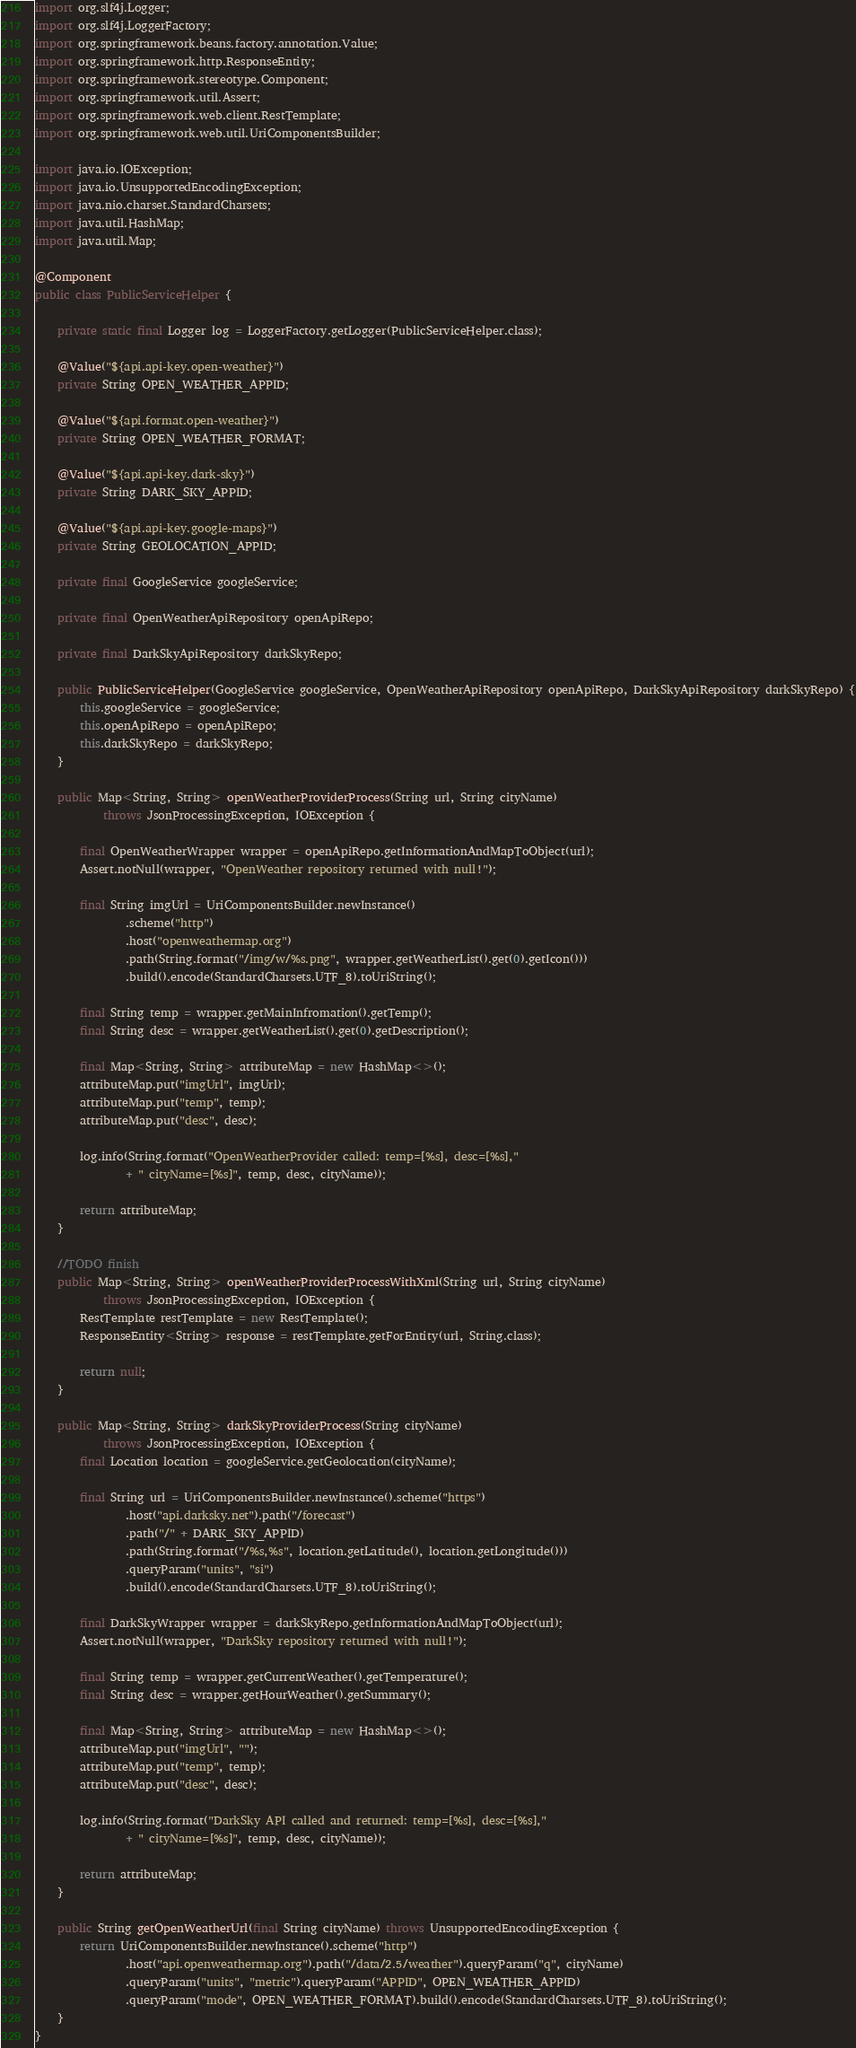<code> <loc_0><loc_0><loc_500><loc_500><_Java_>import org.slf4j.Logger;
import org.slf4j.LoggerFactory;
import org.springframework.beans.factory.annotation.Value;
import org.springframework.http.ResponseEntity;
import org.springframework.stereotype.Component;
import org.springframework.util.Assert;
import org.springframework.web.client.RestTemplate;
import org.springframework.web.util.UriComponentsBuilder;

import java.io.IOException;
import java.io.UnsupportedEncodingException;
import java.nio.charset.StandardCharsets;
import java.util.HashMap;
import java.util.Map;

@Component
public class PublicServiceHelper {
    
    private static final Logger log = LoggerFactory.getLogger(PublicServiceHelper.class);
    
    @Value("${api.api-key.open-weather}")
    private String OPEN_WEATHER_APPID;

    @Value("${api.format.open-weather}")
    private String OPEN_WEATHER_FORMAT;

    @Value("${api.api-key.dark-sky}")
    private String DARK_SKY_APPID;

    @Value("${api.api-key.google-maps}")
    private String GEOLOCATION_APPID;
    
    private final GoogleService googleService;
    
    private final OpenWeatherApiRepository openApiRepo;
    
    private final DarkSkyApiRepository darkSkyRepo;
    
    public PublicServiceHelper(GoogleService googleService, OpenWeatherApiRepository openApiRepo, DarkSkyApiRepository darkSkyRepo) {
        this.googleService = googleService;
        this.openApiRepo = openApiRepo;
        this.darkSkyRepo = darkSkyRepo;
    }

    public Map<String, String> openWeatherProviderProcess(String url, String cityName)
            throws JsonProcessingException, IOException {

        final OpenWeatherWrapper wrapper = openApiRepo.getInformationAndMapToObject(url);
        Assert.notNull(wrapper, "OpenWeather repository returned with null!");

        final String imgUrl = UriComponentsBuilder.newInstance()
                .scheme("http")
                .host("openweathermap.org")
                .path(String.format("/img/w/%s.png", wrapper.getWeatherList().get(0).getIcon()))
                .build().encode(StandardCharsets.UTF_8).toUriString();
                        
        final String temp = wrapper.getMainInfromation().getTemp();
        final String desc = wrapper.getWeatherList().get(0).getDescription();
        
        final Map<String, String> attributeMap = new HashMap<>();
        attributeMap.put("imgUrl", imgUrl);
        attributeMap.put("temp", temp);
        attributeMap.put("desc", desc);
        
        log.info(String.format("OpenWeatherProvider called: temp=[%s], desc=[%s],"
                + " cityName=[%s]", temp, desc, cityName));
        
        return attributeMap;
    }
    
    //TODO finish
    public Map<String, String> openWeatherProviderProcessWithXml(String url, String cityName)
            throws JsonProcessingException, IOException {
        RestTemplate restTemplate = new RestTemplate();
        ResponseEntity<String> response = restTemplate.getForEntity(url, String.class);

        return null;
    }
    
    public Map<String, String> darkSkyProviderProcess(String cityName)
            throws JsonProcessingException, IOException {
        final Location location = googleService.getGeolocation(cityName);

        final String url = UriComponentsBuilder.newInstance().scheme("https")
                .host("api.darksky.net").path("/forecast")
                .path("/" + DARK_SKY_APPID)
                .path(String.format("/%s,%s", location.getLatitude(), location.getLongitude()))
                .queryParam("units", "si")
                .build().encode(StandardCharsets.UTF_8).toUriString();

        final DarkSkyWrapper wrapper = darkSkyRepo.getInformationAndMapToObject(url);
        Assert.notNull(wrapper, "DarkSky repository returned with null!");
        
        final String temp = wrapper.getCurrentWeather().getTemperature();
        final String desc = wrapper.getHourWeather().getSummary();
        
        final Map<String, String> attributeMap = new HashMap<>();
        attributeMap.put("imgUrl", "");
        attributeMap.put("temp", temp);
        attributeMap.put("desc", desc);
        
        log.info(String.format("DarkSky API called and returned: temp=[%s], desc=[%s],"
                + " cityName=[%s]", temp, desc, cityName));
        
        return attributeMap;
    }

    public String getOpenWeatherUrl(final String cityName) throws UnsupportedEncodingException {
        return UriComponentsBuilder.newInstance().scheme("http")
                .host("api.openweathermap.org").path("/data/2.5/weather").queryParam("q", cityName)
                .queryParam("units", "metric").queryParam("APPID", OPEN_WEATHER_APPID)
                .queryParam("mode", OPEN_WEATHER_FORMAT).build().encode(StandardCharsets.UTF_8).toUriString();
    }
}
</code> 